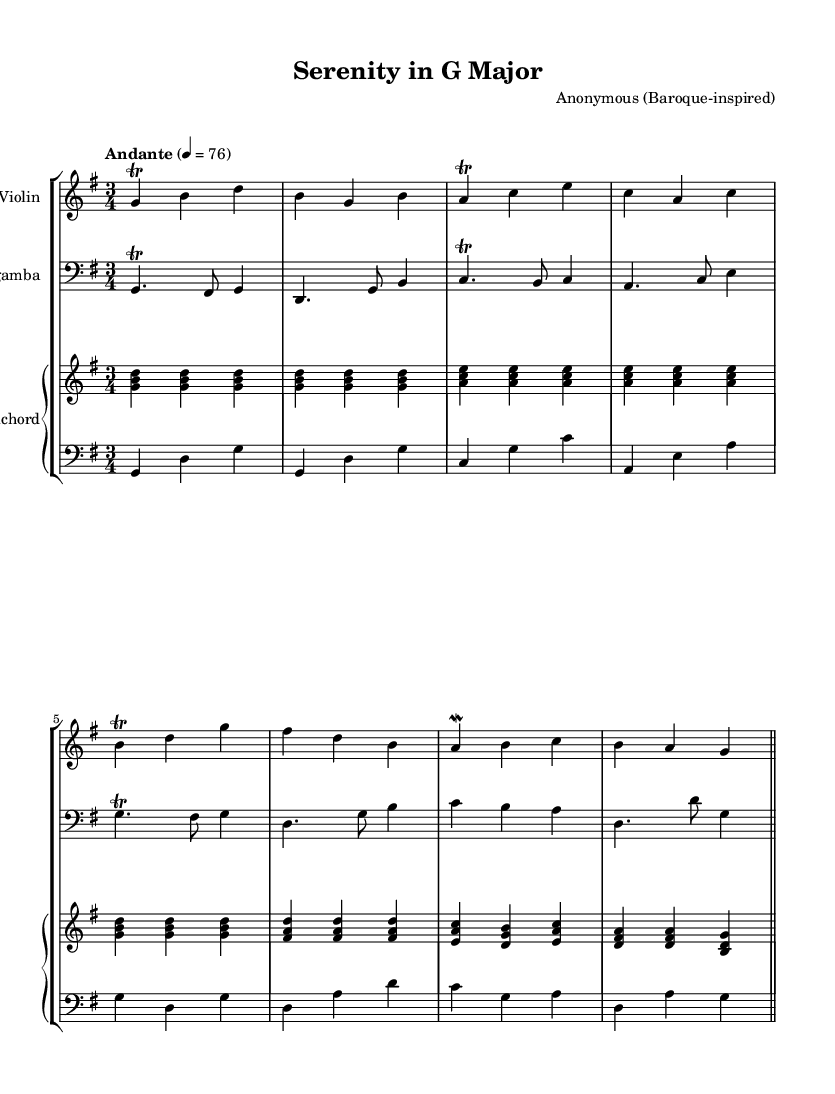What is the key signature of this music? The key signature shows one sharp (F#) and indicates the music is in G major, which is characterized by the presence of F# as the only sharp note.
Answer: G major What is the time signature of this piece? The time signature is represented at the beginning of the score as 3/4, meaning there are three beats per measure, and the quarter note gets one beat.
Answer: 3/4 What is the tempo marking for this composition? The tempo marking listed in the score indicates "Andante" with a metronome marking of 76, suggesting a moderate walking pace for performance.
Answer: Andante How many instruments are featured in the chamber music? By counting the staves in the score, there are four distinct parts (Violin, Viola da gamba, Harpsichord right hand, and Harpsichord left hand), indicating a total of four instruments in this chamber music piece.
Answer: Four What specific ornamentation is present for the Violin part? The score shows the use of trills and mordents in the Violin part, which are typical ornamentations in Baroque music, enhancing expressiveness and complexity.
Answer: Trills and mordents Which instrument plays the bass line? The Viola da gamba part is notated in the bass clef, indicating it plays the lower bass line along with the left hand of the Harpsichord.
Answer: Viola da gamba What is the function of the harpsichord in this composition? The harpsichord serves both harmonic accompaniment and texture, providing chordal support and enriching the overall sound with both right-hand and left-hand parts.
Answer: Harmonic accompaniment 